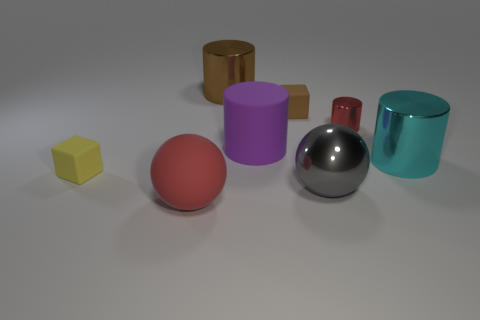There is a large gray object; what number of red shiny cylinders are in front of it?
Provide a short and direct response. 0. How many tiny gray objects have the same material as the small red object?
Your answer should be compact. 0. Do the cube that is in front of the small red metallic thing and the large cyan object have the same material?
Ensure brevity in your answer.  No. Is there a big brown rubber object?
Offer a very short reply. No. How big is the metal thing that is both behind the tiny yellow matte object and to the left of the small red cylinder?
Ensure brevity in your answer.  Large. Is the number of small yellow objects to the right of the small yellow matte object greater than the number of tiny rubber objects that are in front of the big purple thing?
Keep it short and to the point. No. There is a shiny thing that is the same color as the rubber ball; what is its size?
Your response must be concise. Small. What is the color of the rubber cylinder?
Offer a very short reply. Purple. What is the color of the big thing that is both in front of the big purple matte cylinder and on the left side of the brown rubber cube?
Your answer should be very brief. Red. There is a block right of the big purple cylinder that is on the right side of the tiny cube that is in front of the cyan thing; what is its color?
Make the answer very short. Brown. 